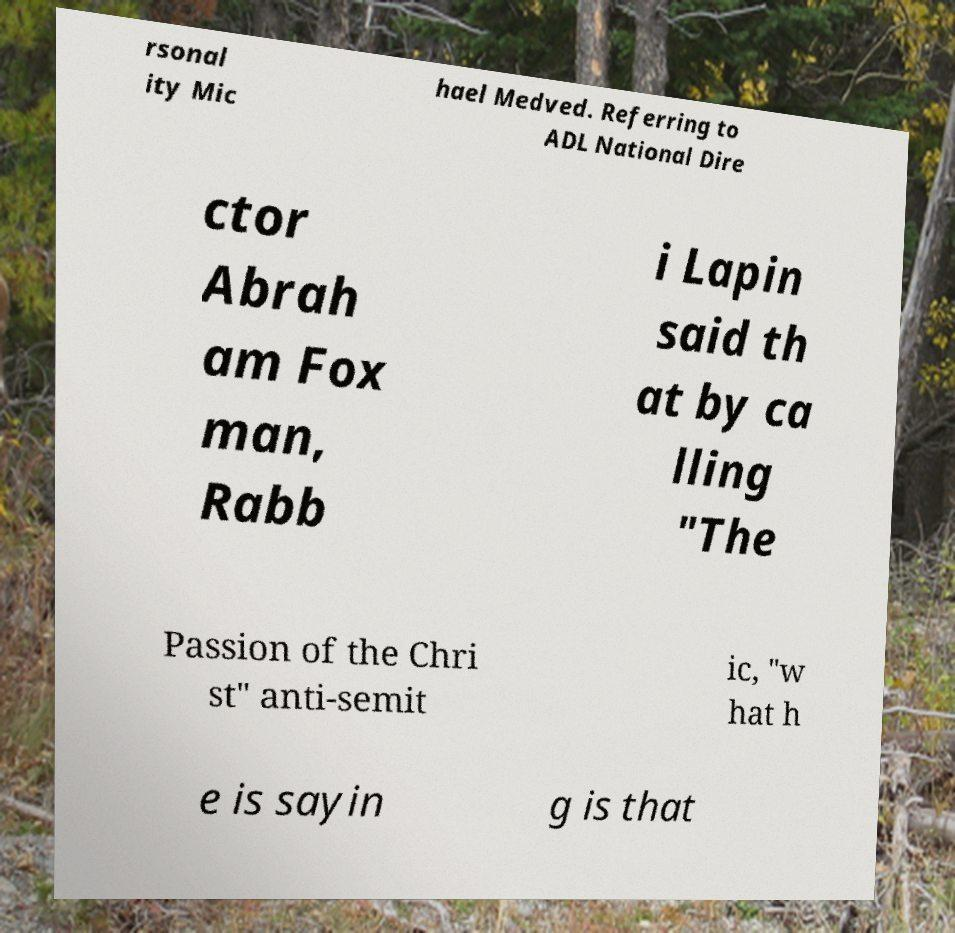Please read and relay the text visible in this image. What does it say? rsonal ity Mic hael Medved. Referring to ADL National Dire ctor Abrah am Fox man, Rabb i Lapin said th at by ca lling "The Passion of the Chri st" anti-semit ic, "w hat h e is sayin g is that 